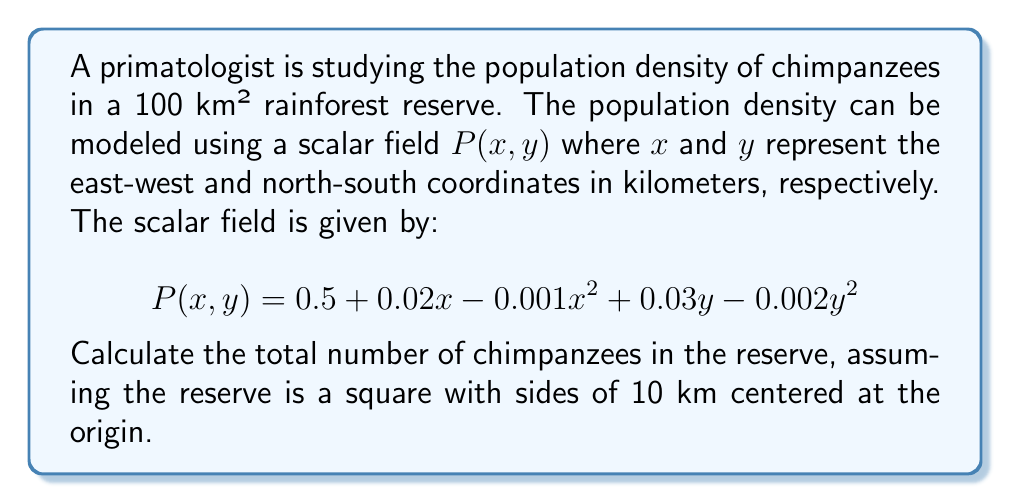Can you solve this math problem? To solve this problem, we need to integrate the scalar field over the given area. The steps are as follows:

1) The limits of integration for both x and y are from -5 to 5, as the 10 km x 10 km square is centered at the origin.

2) Set up the double integral:

   $$N = \int_{-5}^{5} \int_{-5}^{5} P(x,y) \, dx \, dy$$

3) Substitute the given scalar field:

   $$N = \int_{-5}^{5} \int_{-5}^{5} (0.5 + 0.02x - 0.001x^2 + 0.03y - 0.002y^2) \, dx \, dy$$

4) Integrate with respect to x:

   $$N = \int_{-5}^{5} [0.5x + 0.01x^2 - \frac{1}{3}0.001x^3 + 0.03xy - 0.002y^2x]_{-5}^{5} \, dy$$

5) Evaluate the inner integral:

   $$N = \int_{-5}^{5} (5 + 0.25 - 0.0416667 + 0.15y - 0.01y^2) - (-5 + 0.25 - 0.0416667 - 0.15y + 0.01y^2) \, dy$$
   
   $$N = \int_{-5}^{5} (10 + 0.3y - 0.02y^2) \, dy$$

6) Integrate with respect to y:

   $$N = [10y + 0.15y^2 - \frac{1}{3}0.02y^3]_{-5}^{5}$$

7) Evaluate the outer integral:

   $$N = (50 + 3.75 - 0.8333) - (-50 + 3.75 - 0.8333)$$
   
   $$N = 100$$

Therefore, the total number of chimpanzees in the reserve is 100.
Answer: 100 chimpanzees 